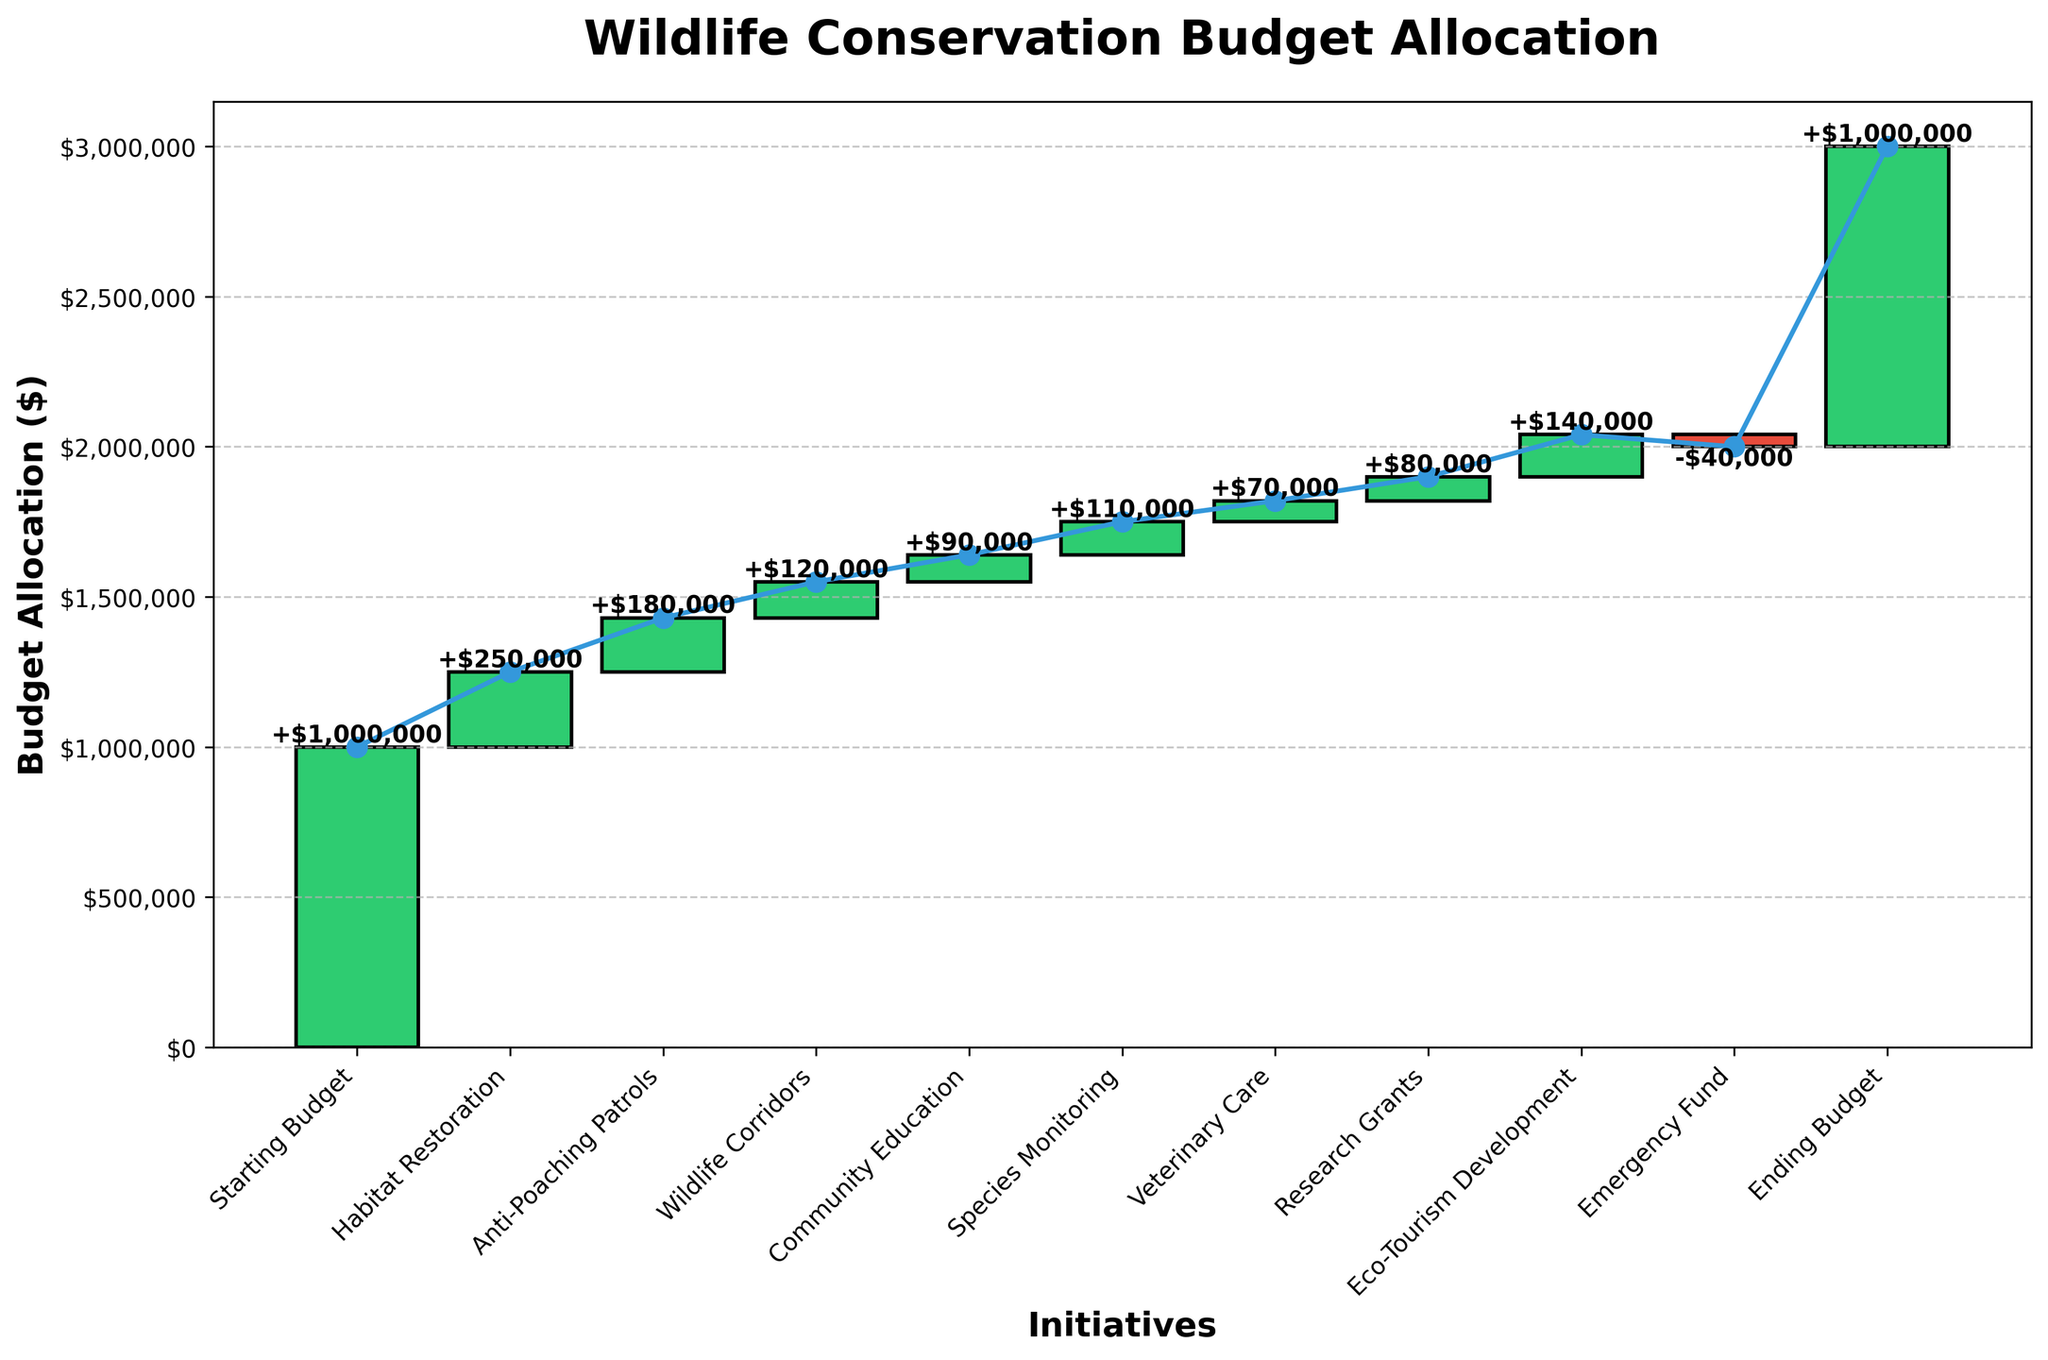What is the title of the chart? The title is located at the top of the chart and is often bold and larger than the rest of the text.
Answer: Wildlife Conservation Budget Allocation Which initiative received the highest budget allocation? By examining the heights of the bars, we can see which bar is the tallest.
Answer: Habitat Restoration What is the ending budget after all allocations? The ending budget is the final cumulative value shown on the chart, which is labeled on the last segment.
Answer: $1,000,000 How many initiatives are there in total? Count the number of bars or labels on the x-axis. Each initiative is represented by a bar.
Answer: 10 What is the cumulative budget after the allocation for Anti-Poaching Patrols? Find the cumulative line value after the Anti-Poaching Patrols bar. This is the cumulative budget after that initiative is applied.
Answer: $1,430,000 How does the budget allocation for Community Education compare to Veterinary Care? Compare the heights of the bars or the values at the top of each respective bar.
Answer: Community Education received more ($90,000 vs. $70,000) What is the total budget allocated for species monitoring and research grants? Add the budget allocations for Species Monitoring and Research Grants by summing their values.
Answer: $190,000 Which initiative led to a reduction in the budget? Identify the bar that is below the baseline or uses a different color (typically red).
Answer: Emergency Fund What is the cumulative budget after Eco-Tourism Development? Locate the cumulative line value right after the Eco-Tourism Development bar.
Answer: $2,020,000 What is the net change in budget allocation for all initiatives combined? Calculate the difference between the starting budget and the ending budget directly.
Answer: $0 